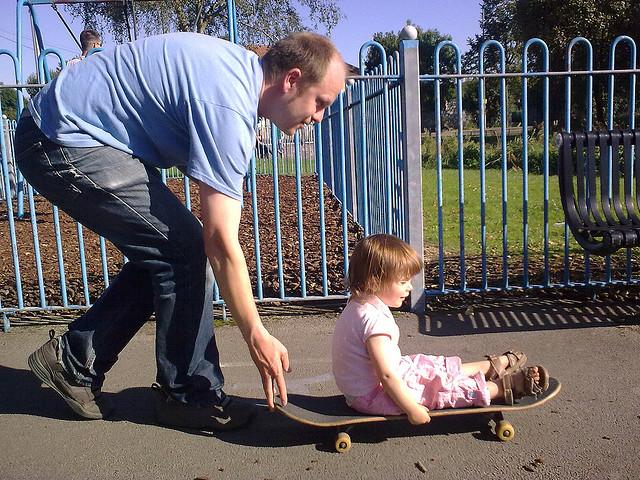What is the material on the ground in the background?
Be succinct. Mulch. Is the child wearing sneakers?
Short answer required. No. What relationship do you think this is?
Keep it brief. Father daughter. 